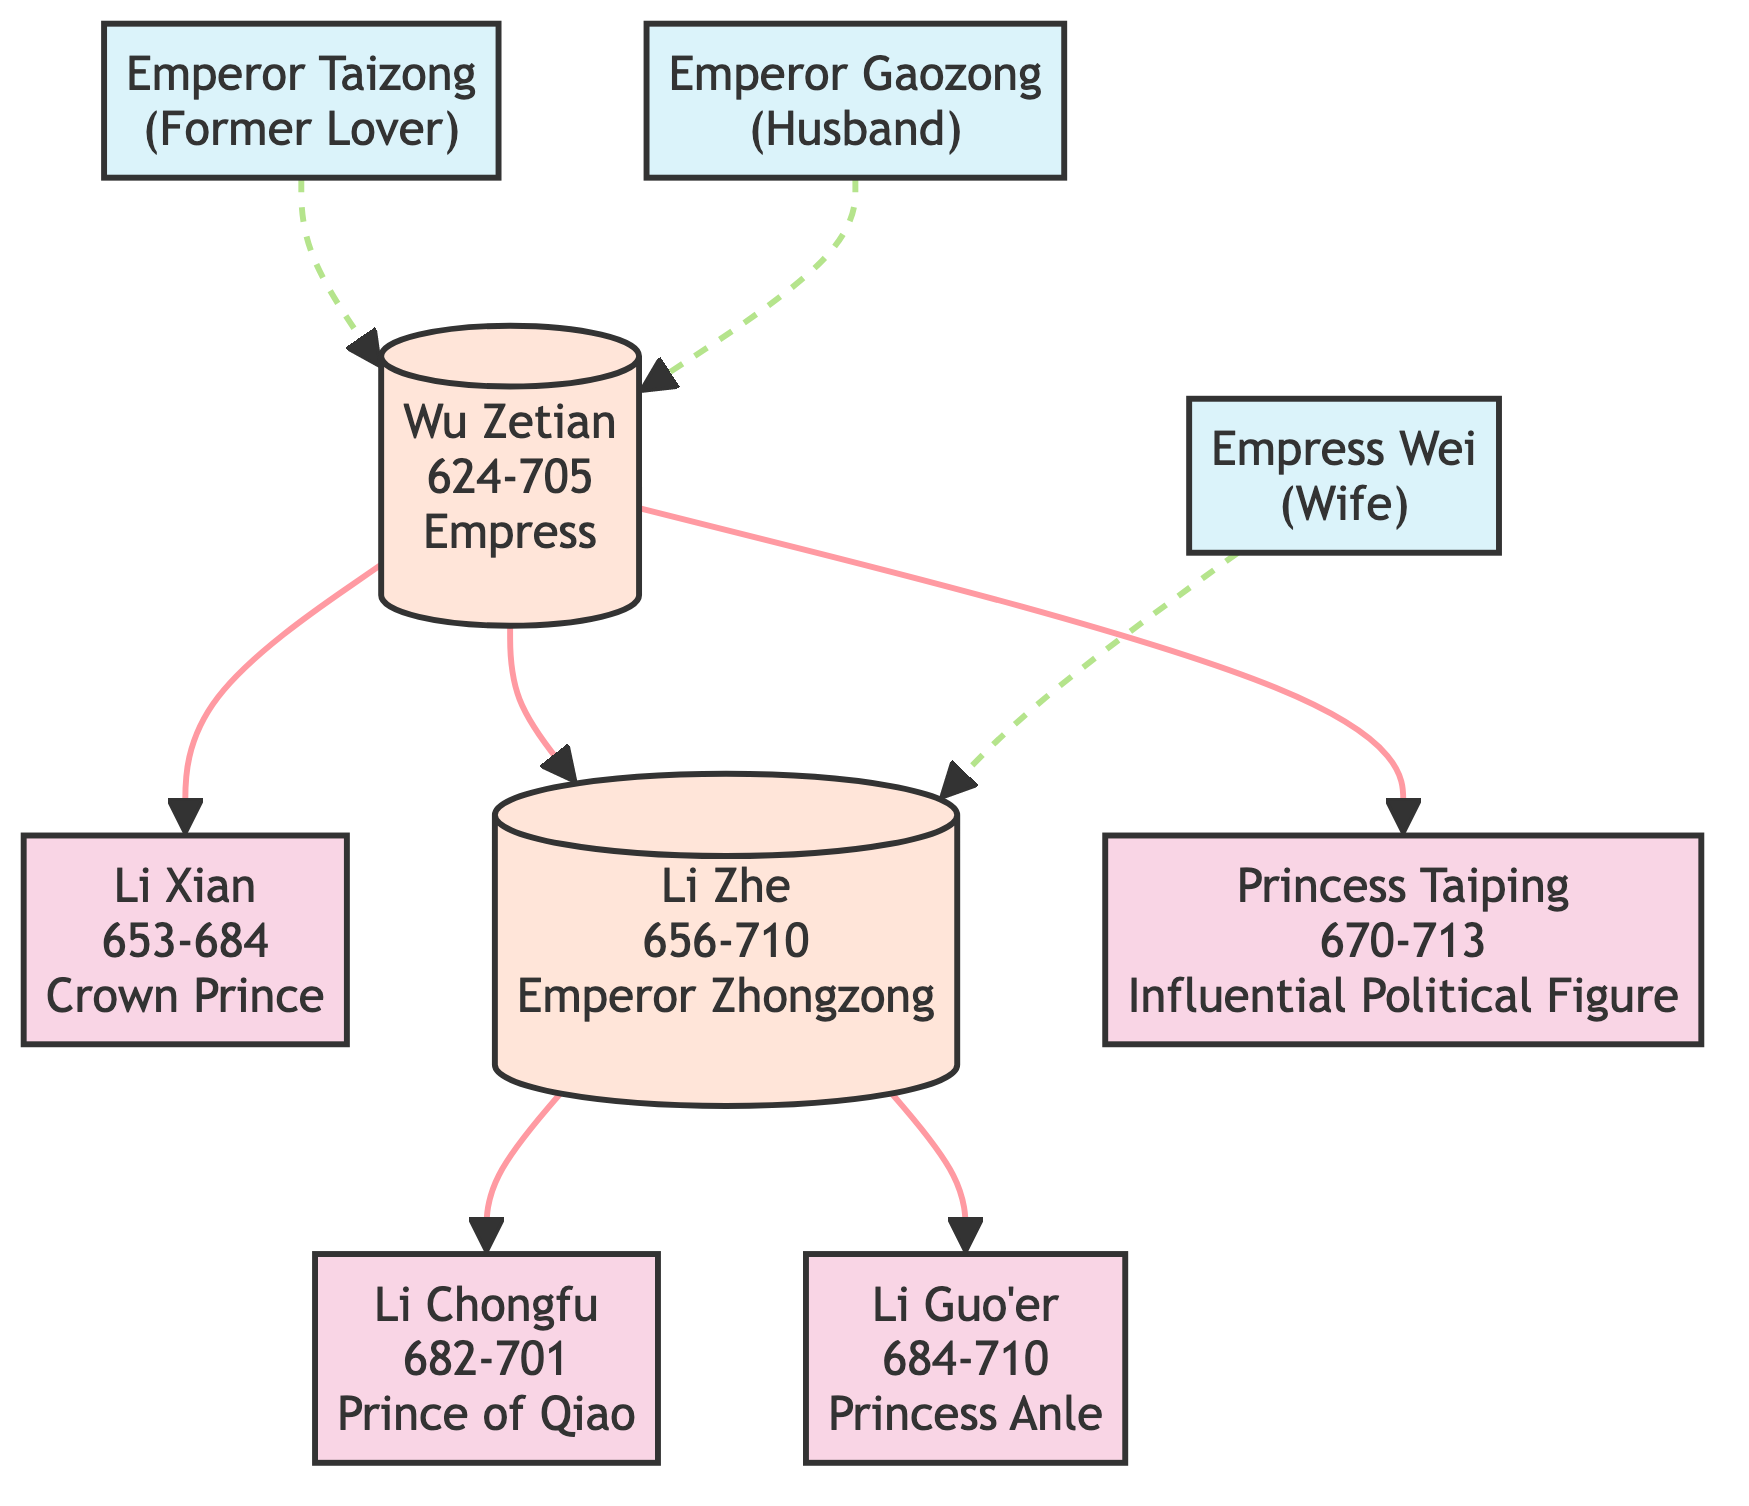What is the birth year of Wu Zetian? The diagram lists Wu Zetian's birth year directly as 624.
Answer: 624 How many children did Wu Zetian have? Through the diagram, we see that Wu Zetian has three children connected to her node: Li Xian, Li Zhe, and Princess Taiping.
Answer: 3 Who is the spouse of Li Zhe? According to the diagram, Li Zhe's spouse is Empress Wei, as indicated by the line connecting them.
Answer: Empress Wei What is the role of Princess Taiping? The diagram identifies Princess Taiping as an "Influential Political Figure."
Answer: Influential Political Figure How many emperors are represented in the diagram? Analyzing the diagram reveals that there are two emperors: Wu Zetian (as Empress, also an emperor in a non-traditional sense) and Li Zhe (Emperor Zhongzong).
Answer: 2 What is the death year of Li Guo'er? The diagram provides the death year of Li Guo'er as 710.
Answer: 710 Which node has a dashed connection? The diagram shows a dashed line from the node for Emperor Taizong to Wu Zetian, indicating a former relationship.
Answer: Emperor Taizong What is the relationship between Wu Zetian and Emperor Gaozong? The diagram states that Emperor Gaozong is the husband of Wu Zetian, as illustrated by the solid line connecting them.
Answer: husband Is Princess Anle a direct descendant of Wu Zetian? The diagram shows that Princess Anle is a child of Li Zhe, who is a child of Wu Zetian, confirming the direct descendant relationship.
Answer: Yes 